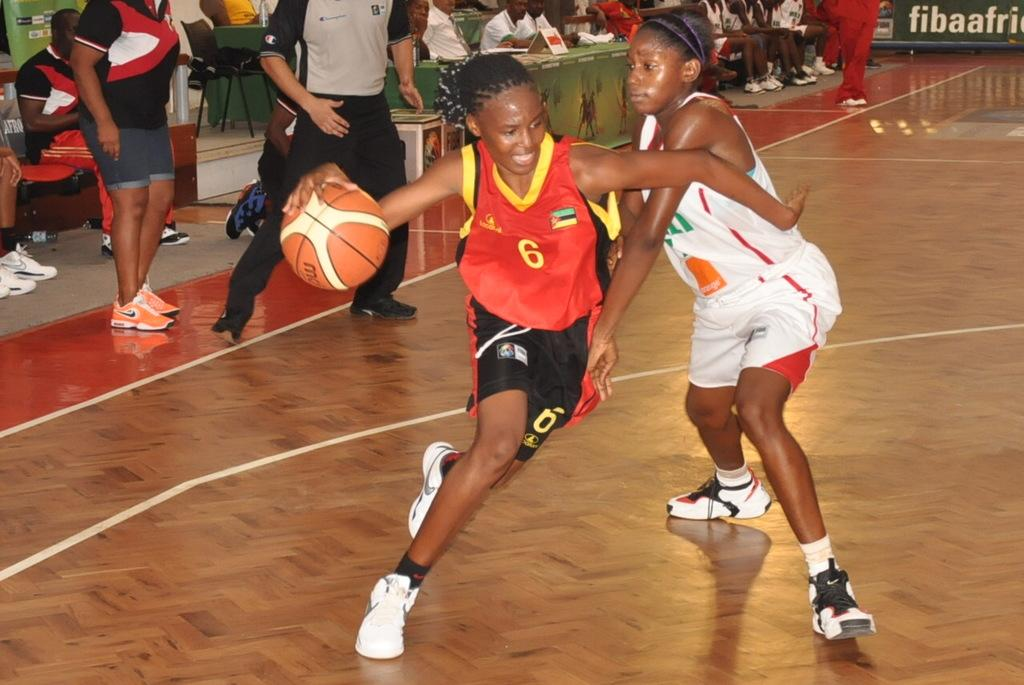<image>
Summarize the visual content of the image. A child wearing a jersey with the number 6 is trying to keep possession of the basketball during a game. 